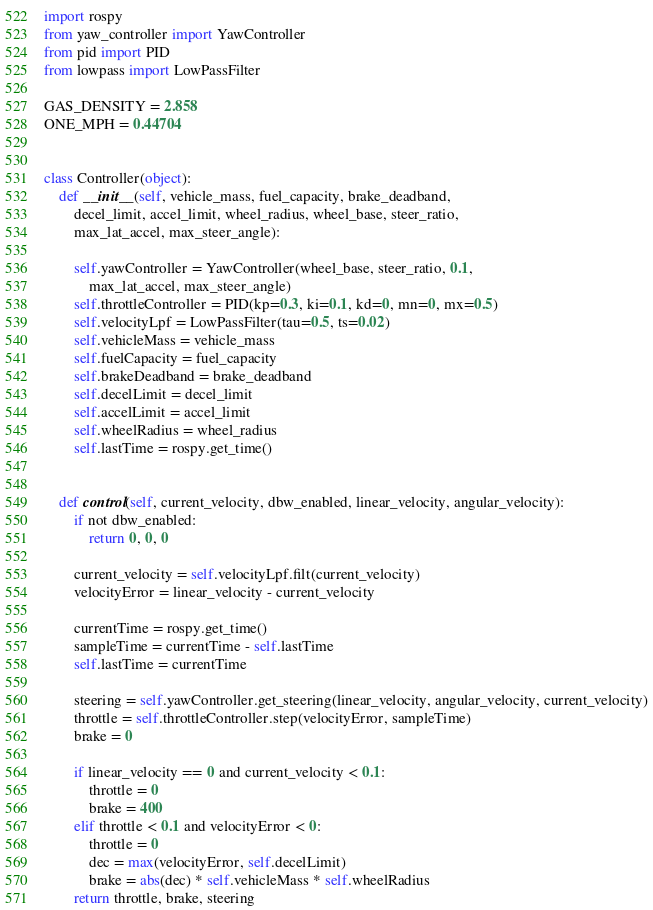Convert code to text. <code><loc_0><loc_0><loc_500><loc_500><_Python_>import rospy
from yaw_controller import YawController
from pid import PID
from lowpass import LowPassFilter

GAS_DENSITY = 2.858
ONE_MPH = 0.44704


class Controller(object):
    def __init__(self, vehicle_mass, fuel_capacity, brake_deadband,
        decel_limit, accel_limit, wheel_radius, wheel_base, steer_ratio,
        max_lat_accel, max_steer_angle):
        
        self.yawController = YawController(wheel_base, steer_ratio, 0.1,
            max_lat_accel, max_steer_angle)
        self.throttleController = PID(kp=0.3, ki=0.1, kd=0, mn=0, mx=0.5)
        self.velocityLpf = LowPassFilter(tau=0.5, ts=0.02)
        self.vehicleMass = vehicle_mass
        self.fuelCapacity = fuel_capacity
        self.brakeDeadband = brake_deadband
        self.decelLimit = decel_limit
        self.accelLimit = accel_limit
        self.wheelRadius = wheel_radius
        self.lastTime = rospy.get_time()


    def control(self, current_velocity, dbw_enabled, linear_velocity, angular_velocity):
        if not dbw_enabled:
            return 0, 0, 0

        current_velocity = self.velocityLpf.filt(current_velocity)
        velocityError = linear_velocity - current_velocity
        
        currentTime = rospy.get_time()
        sampleTime = currentTime - self.lastTime
        self.lastTime = currentTime

        steering = self.yawController.get_steering(linear_velocity, angular_velocity, current_velocity)
        throttle = self.throttleController.step(velocityError, sampleTime)
        brake = 0

        if linear_velocity == 0 and current_velocity < 0.1:
            throttle = 0
            brake = 400
        elif throttle < 0.1 and velocityError < 0:
            throttle = 0
            dec = max(velocityError, self.decelLimit)
            brake = abs(dec) * self.vehicleMass * self.wheelRadius
        return throttle, brake, steering
</code> 